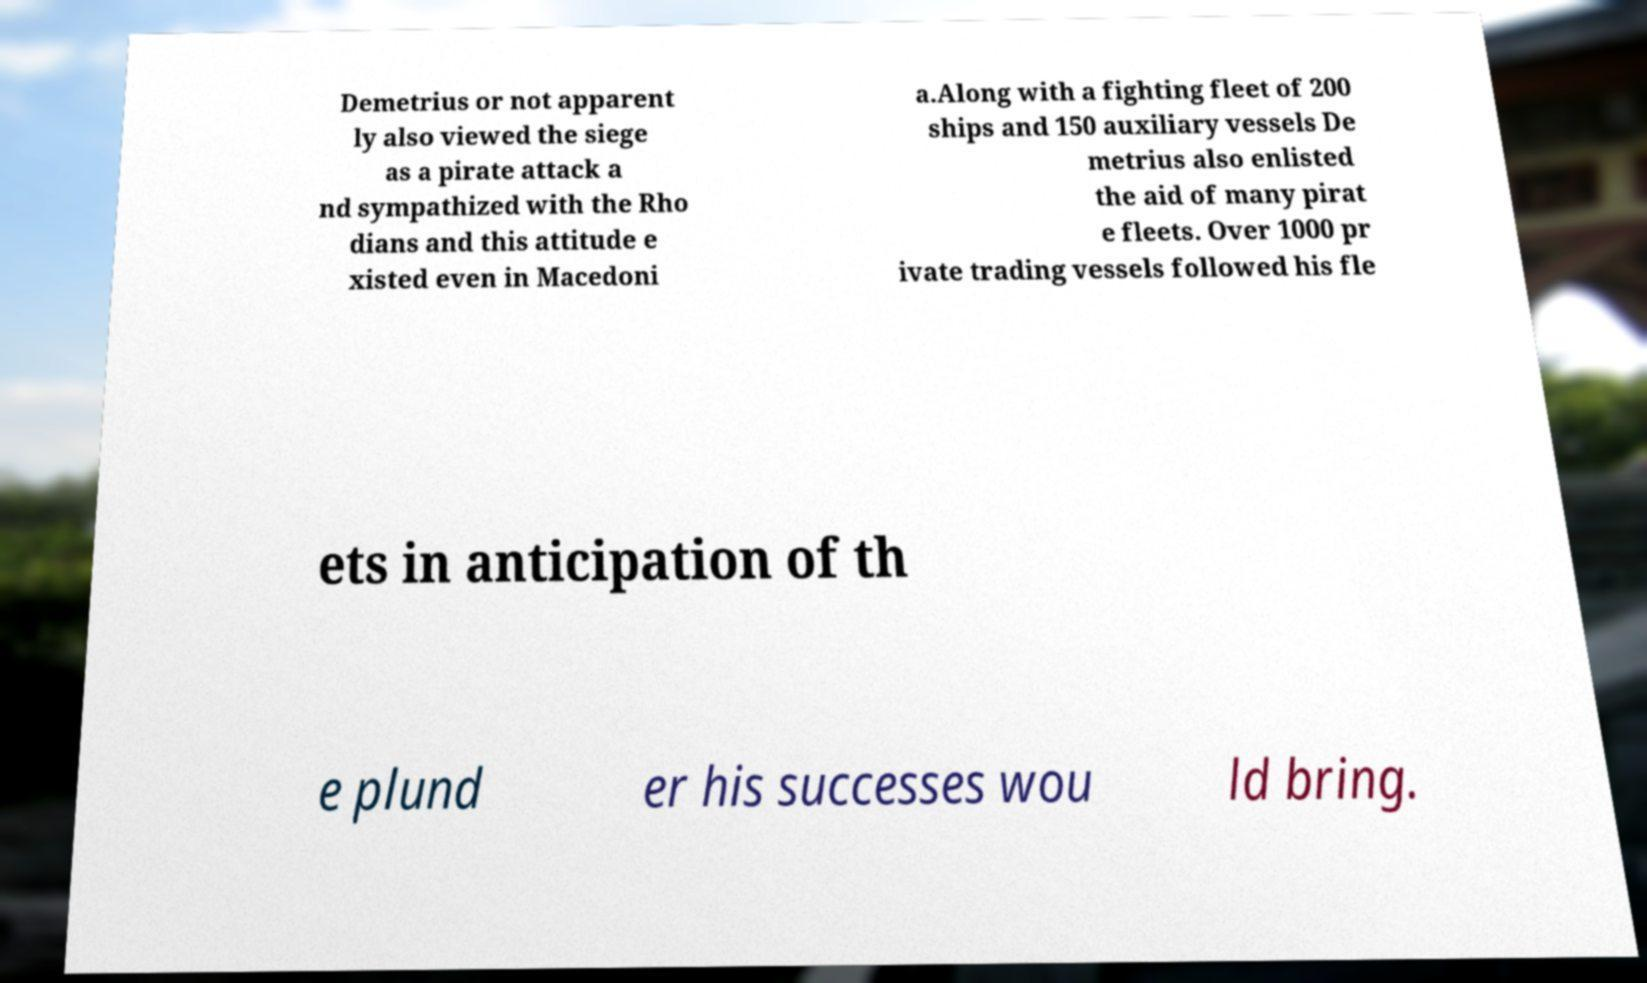Could you extract and type out the text from this image? Demetrius or not apparent ly also viewed the siege as a pirate attack a nd sympathized with the Rho dians and this attitude e xisted even in Macedoni a.Along with a fighting fleet of 200 ships and 150 auxiliary vessels De metrius also enlisted the aid of many pirat e fleets. Over 1000 pr ivate trading vessels followed his fle ets in anticipation of th e plund er his successes wou ld bring. 